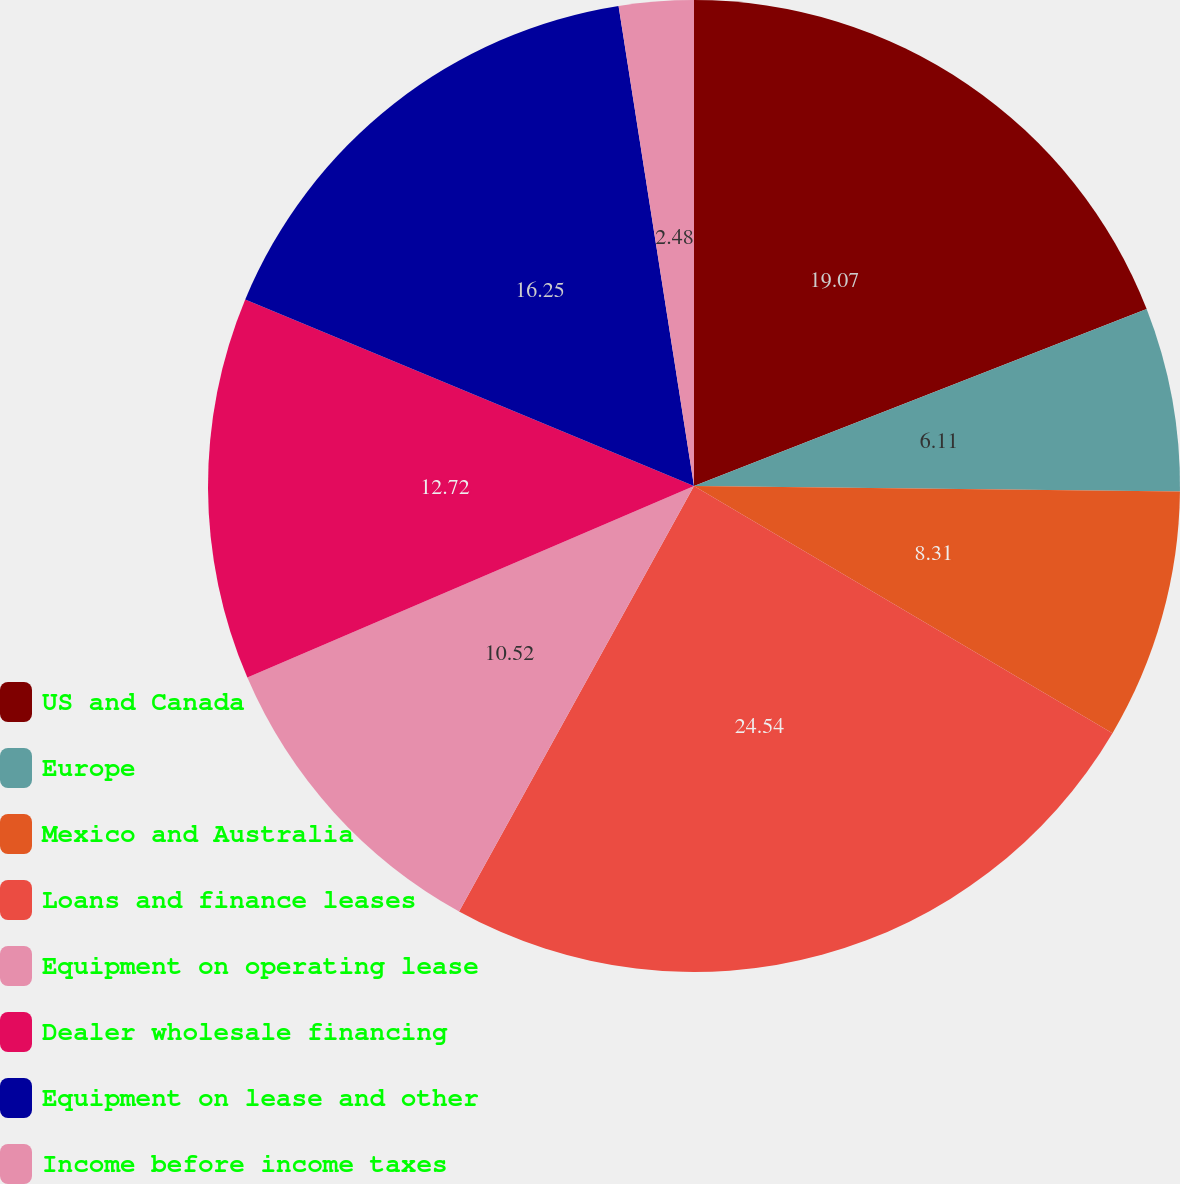Convert chart to OTSL. <chart><loc_0><loc_0><loc_500><loc_500><pie_chart><fcel>US and Canada<fcel>Europe<fcel>Mexico and Australia<fcel>Loans and finance leases<fcel>Equipment on operating lease<fcel>Dealer wholesale financing<fcel>Equipment on lease and other<fcel>Income before income taxes<nl><fcel>19.07%<fcel>6.11%<fcel>8.31%<fcel>24.54%<fcel>10.52%<fcel>12.72%<fcel>16.25%<fcel>2.48%<nl></chart> 